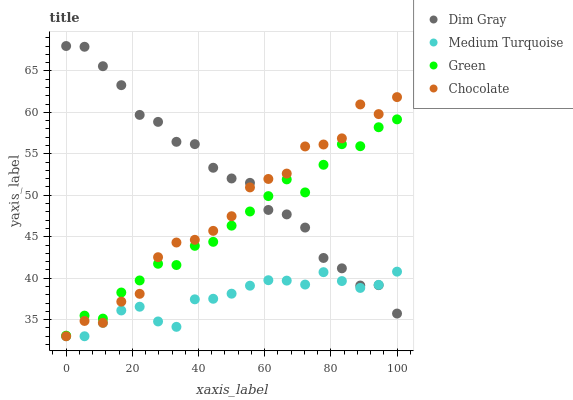Does Medium Turquoise have the minimum area under the curve?
Answer yes or no. Yes. Does Dim Gray have the maximum area under the curve?
Answer yes or no. Yes. Does Green have the minimum area under the curve?
Answer yes or no. No. Does Green have the maximum area under the curve?
Answer yes or no. No. Is Medium Turquoise the smoothest?
Answer yes or no. Yes. Is Chocolate the roughest?
Answer yes or no. Yes. Is Green the smoothest?
Answer yes or no. No. Is Green the roughest?
Answer yes or no. No. Does Medium Turquoise have the lowest value?
Answer yes or no. Yes. Does Green have the lowest value?
Answer yes or no. No. Does Dim Gray have the highest value?
Answer yes or no. Yes. Does Green have the highest value?
Answer yes or no. No. Is Medium Turquoise less than Green?
Answer yes or no. Yes. Is Green greater than Medium Turquoise?
Answer yes or no. Yes. Does Medium Turquoise intersect Dim Gray?
Answer yes or no. Yes. Is Medium Turquoise less than Dim Gray?
Answer yes or no. No. Is Medium Turquoise greater than Dim Gray?
Answer yes or no. No. Does Medium Turquoise intersect Green?
Answer yes or no. No. 